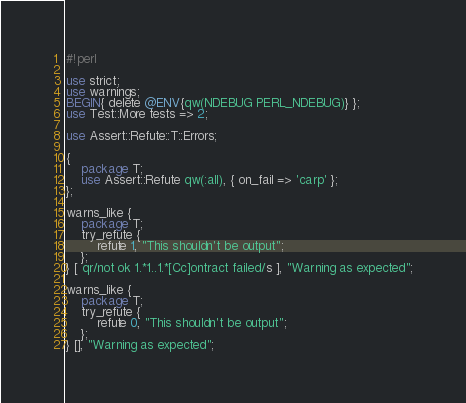<code> <loc_0><loc_0><loc_500><loc_500><_Perl_>#!perl

use strict;
use warnings;
BEGIN{ delete @ENV{qw(NDEBUG PERL_NDEBUG)} };
use Test::More tests => 2;

use Assert::Refute::T::Errors;

{
    package T;
    use Assert::Refute qw(:all), { on_fail => 'carp' };
};

warns_like {
    package T;
    try_refute {
        refute 1, "This shouldn't be output";
    };
} [ qr/not ok 1.*1..1.*[Cc]ontract failed/s ], "Warning as expected";

warns_like {
    package T;
    try_refute {
        refute 0, "This shouldn't be output";
    };
} [], "Warning as expected";

</code> 